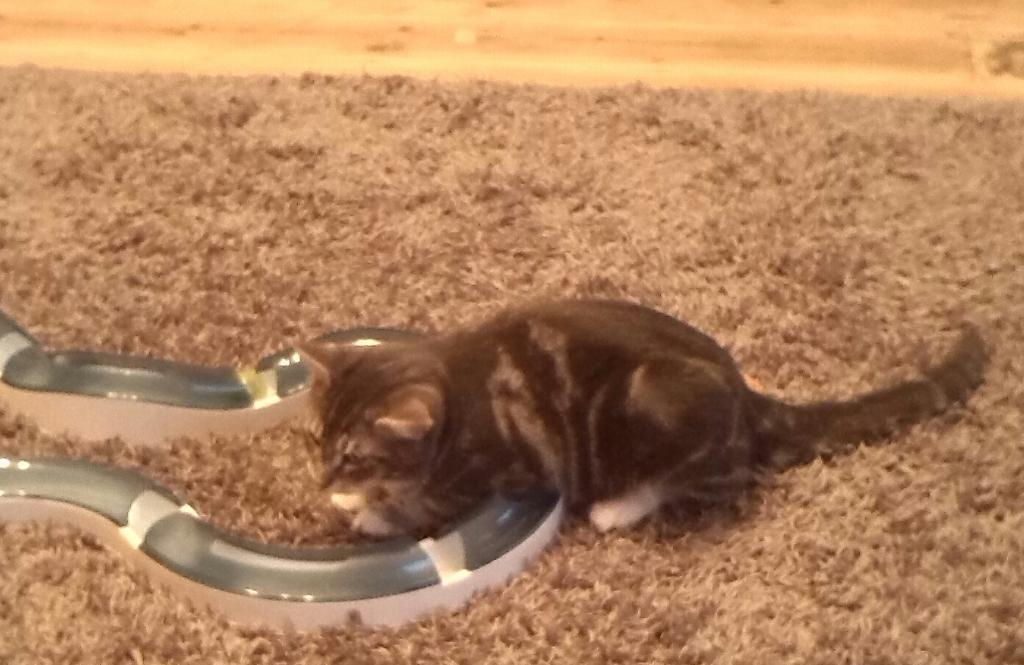What type of animal is in the image? There is a cat in the image. Where is the cat located? The cat is on a floor mat. What type of thrill can be seen on the map in the image? There is no map present in the image, and therefore no thrill can be seen on it. 